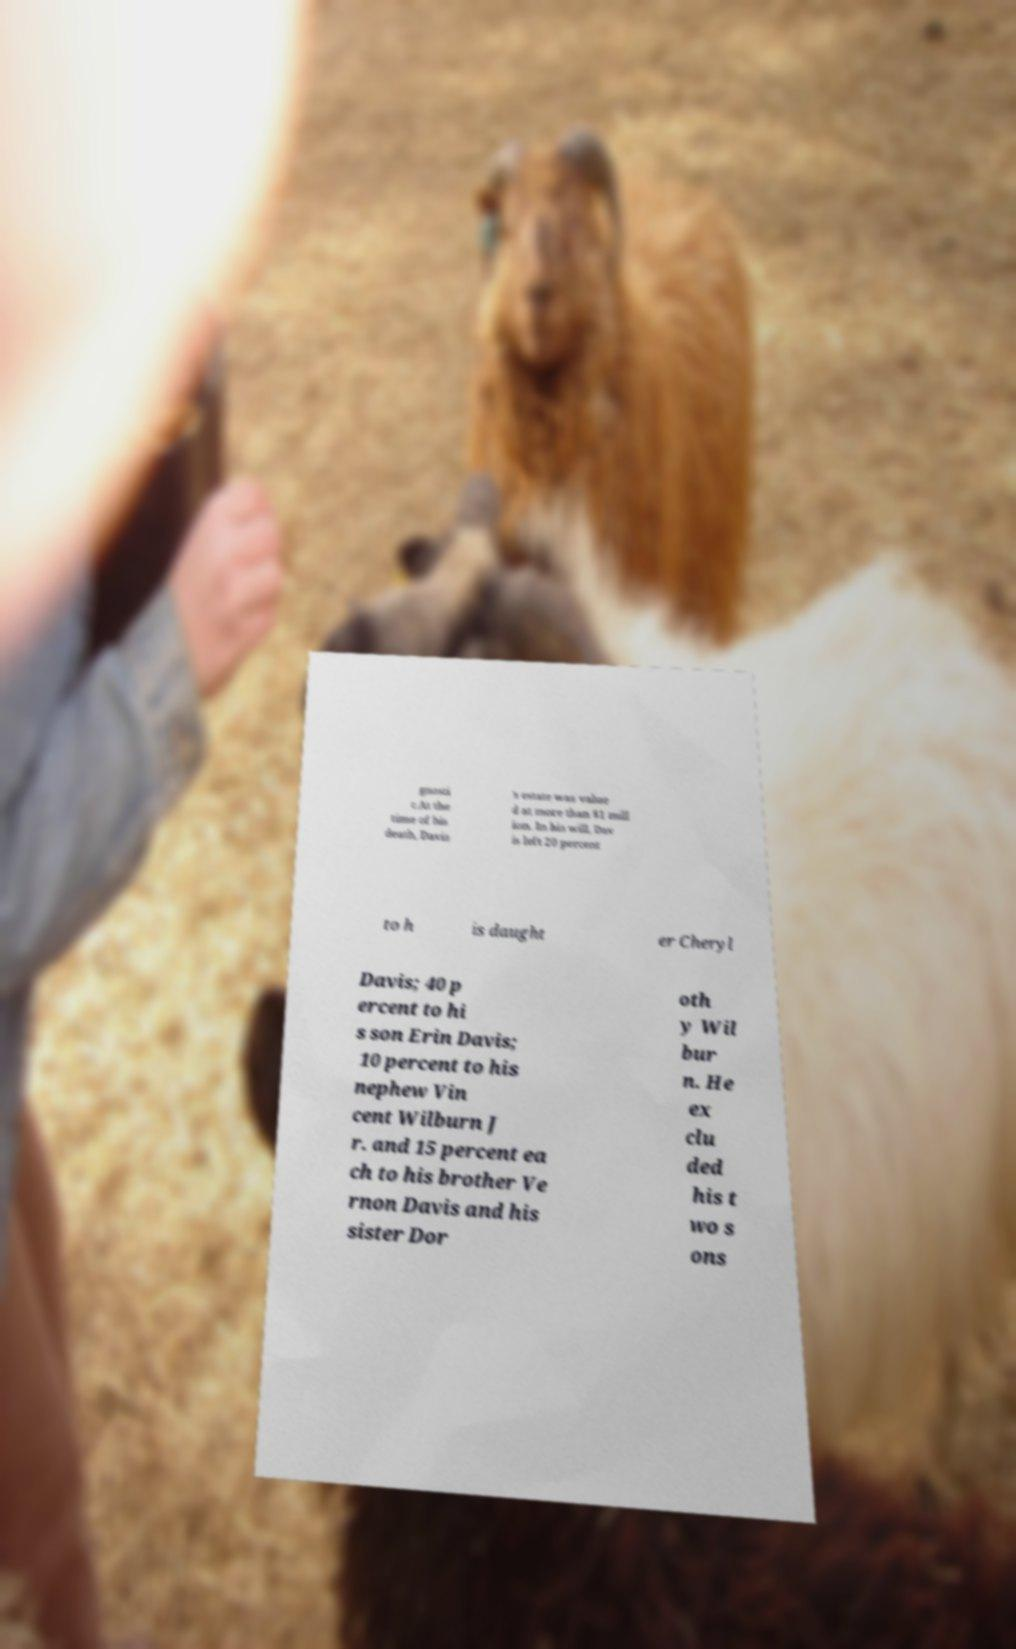Can you read and provide the text displayed in the image?This photo seems to have some interesting text. Can you extract and type it out for me? gnosti c.At the time of his death, Davis 's estate was value d at more than $1 mill ion. In his will, Dav is left 20 percent to h is daught er Cheryl Davis; 40 p ercent to hi s son Erin Davis; 10 percent to his nephew Vin cent Wilburn J r. and 15 percent ea ch to his brother Ve rnon Davis and his sister Dor oth y Wil bur n. He ex clu ded his t wo s ons 